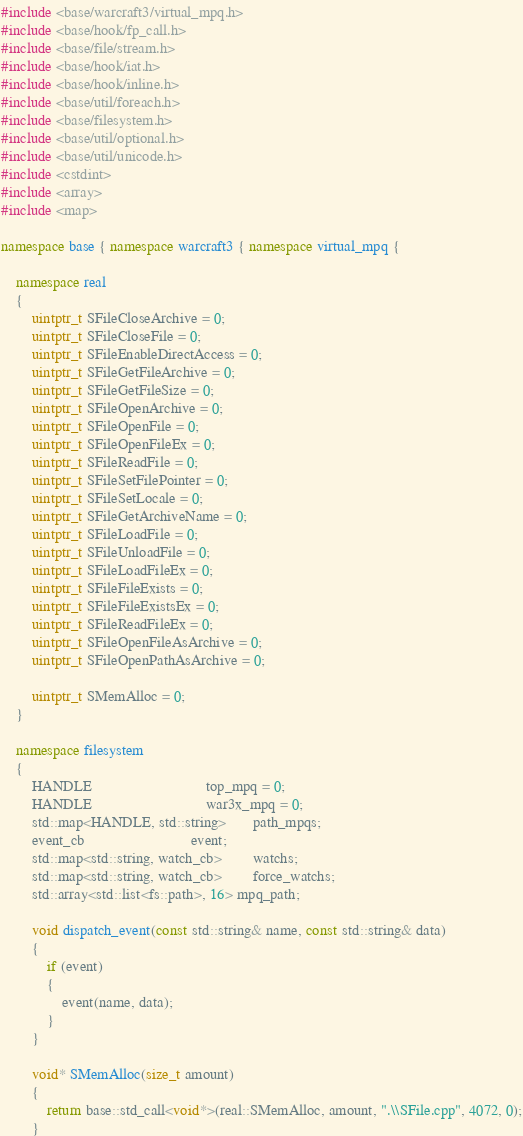Convert code to text. <code><loc_0><loc_0><loc_500><loc_500><_C++_>#include <base/warcraft3/virtual_mpq.h>
#include <base/hook/fp_call.h>
#include <base/file/stream.h>
#include <base/hook/iat.h>
#include <base/hook/inline.h>
#include <base/util/foreach.h>	  	  		
#include <base/filesystem.h>   
#include <base/util/optional.h>
#include <base/util/unicode.h>
#include <cstdint>
#include <array>   
#include <map>

namespace base { namespace warcraft3 { namespace virtual_mpq {

	namespace real
	{
		uintptr_t SFileCloseArchive = 0;
		uintptr_t SFileCloseFile = 0;
		uintptr_t SFileEnableDirectAccess = 0;
		uintptr_t SFileGetFileArchive = 0;
		uintptr_t SFileGetFileSize = 0;
		uintptr_t SFileOpenArchive = 0;
		uintptr_t SFileOpenFile = 0;
		uintptr_t SFileOpenFileEx = 0;
		uintptr_t SFileReadFile = 0;
		uintptr_t SFileSetFilePointer = 0;
		uintptr_t SFileSetLocale = 0;
		uintptr_t SFileGetArchiveName = 0;
		uintptr_t SFileLoadFile = 0;
		uintptr_t SFileUnloadFile = 0;
		uintptr_t SFileLoadFileEx = 0;
		uintptr_t SFileFileExists = 0;
		uintptr_t SFileFileExistsEx = 0;
		uintptr_t SFileReadFileEx = 0;
		uintptr_t SFileOpenFileAsArchive = 0;
		uintptr_t SFileOpenPathAsArchive = 0;

		uintptr_t SMemAlloc = 0;
	}

	namespace filesystem
	{
		HANDLE                              top_mpq = 0;
		HANDLE                              war3x_mpq = 0;
		std::map<HANDLE, std::string>       path_mpqs;
		event_cb	                        event;
		std::map<std::string, watch_cb>	    watchs;
		std::map<std::string, watch_cb>	    force_watchs;
		std::array<std::list<fs::path>, 16> mpq_path;

		void dispatch_event(const std::string& name, const std::string& data)
		{
			if (event)
			{
				event(name, data);
			}
		}

		void* SMemAlloc(size_t amount)
		{
			return base::std_call<void*>(real::SMemAlloc, amount, ".\\SFile.cpp", 4072, 0);
		}
</code> 